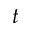Convert formula to latex. <formula><loc_0><loc_0><loc_500><loc_500>t</formula> 